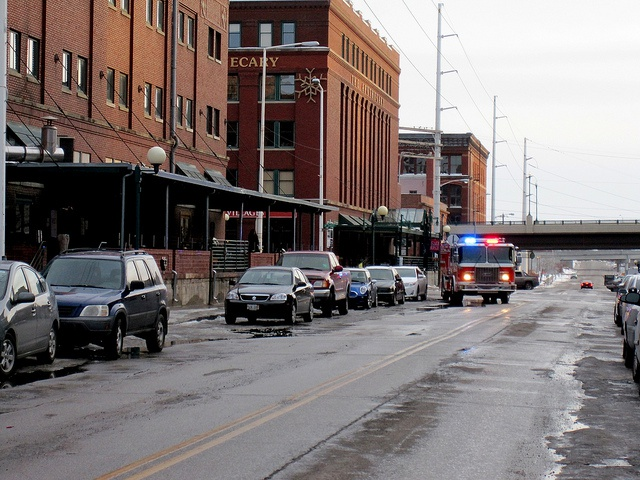Describe the objects in this image and their specific colors. I can see truck in darkgray, black, and gray tones, car in darkgray, black, and gray tones, car in darkgray, gray, black, and lightgray tones, truck in darkgray, black, gray, and maroon tones, and car in darkgray, black, and gray tones in this image. 